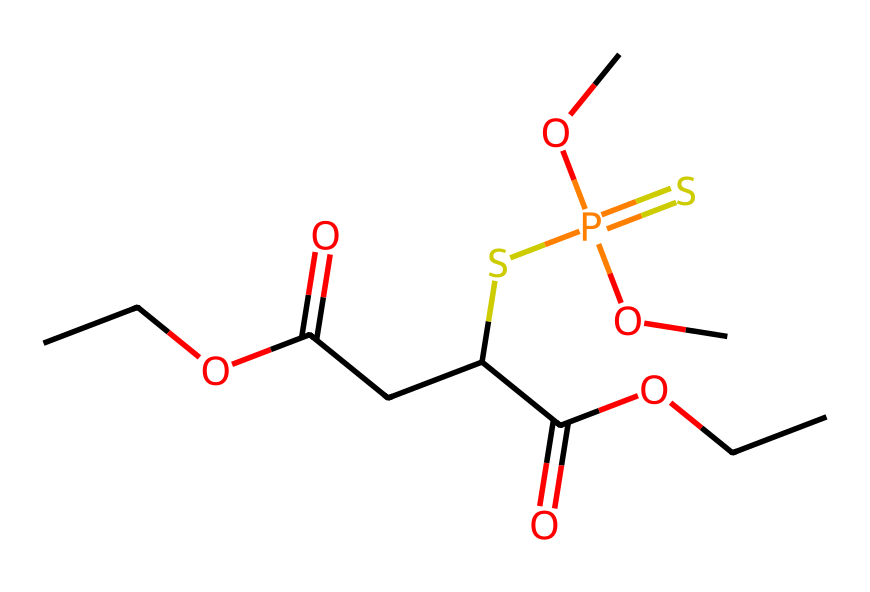What is the molecular formula of malathion? To find the molecular formula, we can analyze the SMILES representation. Counting the carbon (C), hydrogen (H), oxygen (O), and sulfur (S) atoms: There are 13 carbons, 18 hydrogens, 6 oxygens, and 1 sulfur. Thus, the molecular formula is C10H19O6S.
Answer: C10H19O6S How many oxygen atoms are present in this molecule? By examining the SMILES string, we see several occurrences of the oxygen atom (O). Counting these, we find there are 6 oxygen atoms.
Answer: 6 What type of pesticide is malathion? Malathion is an organophosphate insecticide based on its chemical structure which contains phosphorus and sulfur atoms as part of its functional groups.
Answer: organophosphate What functional groups are present in malathion? By analyzing the SMILES structure, we can identify ester (C(=O)O), thioester (SP(=S)(OC)OC), and carboxylic acid (-COOH) functional groups. These characterize malathion's molecular structure.
Answer: ester, thioester, carboxylic acid Which part of the molecule is responsible for its insecticidal activity? The presence of the organophosphate moiety, particularly the phosphorus atom bonded to other functional groups and the sulfur, is crucial for the insecticidal activity as it inhibits enzymes in the nervous system.
Answer: organophosphate moiety 